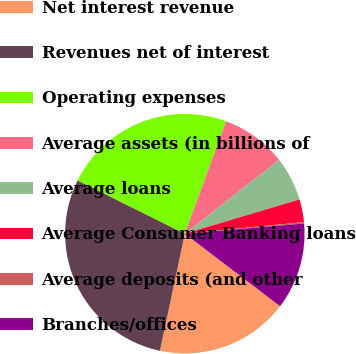Convert chart to OTSL. <chart><loc_0><loc_0><loc_500><loc_500><pie_chart><fcel>Net interest revenue<fcel>Revenues net of interest<fcel>Operating expenses<fcel>Average assets (in billions of<fcel>Average loans<fcel>Average Consumer Banking loans<fcel>Average deposits (and other<fcel>Branches/offices<nl><fcel>17.98%<fcel>29.0%<fcel>23.26%<fcel>8.83%<fcel>5.95%<fcel>3.07%<fcel>0.19%<fcel>11.71%<nl></chart> 